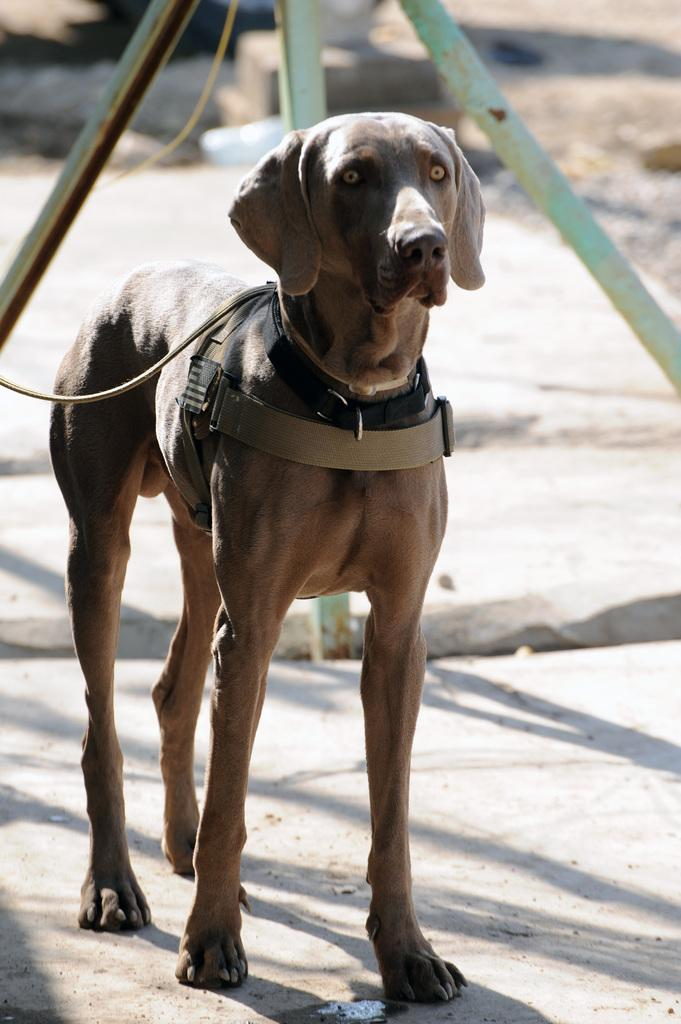What type of animal is present in the image? There is a dog in the image. What can be seen behind the dog? There are metal rods behind the dog. What is the dog's reaction to the alley in the image? There is no alley present in the image, so it is not possible to determine the dog's reaction to it. 